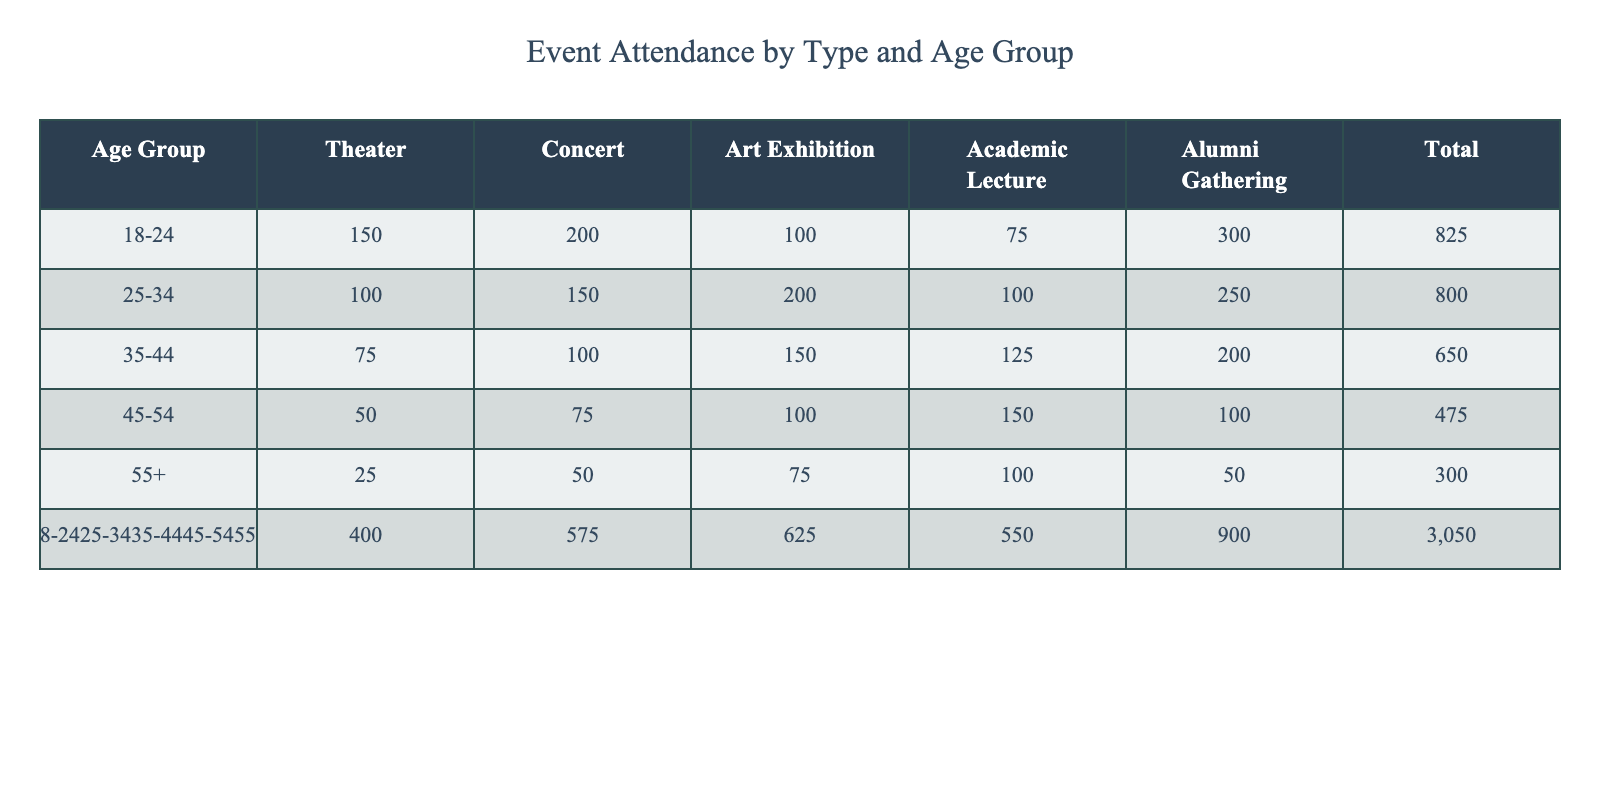What is the total attendance for the 18-24 age group? The total attendance for the 18-24 age group can be found by adding the values from that row. The sum is 150 (Theater) + 200 (Concert) + 100 (Art Exhibition) + 75 (Academic Lecture) + 300 (Alumni Gathering) = 825.
Answer: 825 Which age group had the highest attendance at the Academic Lecture? Upon reviewing the Academic Lecture column, the 35-44 age group has the highest attendance with 125 individuals.
Answer: 35-44 How many attendees were there at the Art Exhibition for those aged 45-54? To find this, we only look at the Art Exhibition column for the 45-54 age group, which shows 100 attendees.
Answer: 100 What is the average attendance for all events from the 55+ age group? The average can be calculated by summing the attendance for the 55+ age group: 25 (Theater) + 50 (Concert) + 75 (Art Exhibition) + 100 (Academic Lecture) + 50 (Alumni Gathering) = 300. Then, divide by the number of events (5), which gives us 300/5 = 60.
Answer: 60 Is the total attendance for the 25-34 age group greater than 600? First, we calculate the total for the 25-34 age group: 100 (Theater) + 150 (Concert) + 200 (Art Exhibition) + 100 (Academic Lecture) + 250 (Alumni Gathering) = 800. Since 800 is greater than 600, the answer is yes.
Answer: Yes Which event type had the least total attendance across all age groups? To find this, we sum each event's attendance across all age groups. Theater = 150 + 100 + 75 + 50 + 25 = 400, Concert = 200 + 150 + 100 + 75 + 50 = 575, Art Exhibition = 100 + 200 + 150 + 100 + 75 = 625, Academic Lecture = 75 + 100 + 125 + 150 + 100 = 550, Alumni Gathering = 300 + 250 + 200 + 100 + 50 = 900. The least is Theatre at 400.
Answer: Theater How many more attendees were there at the Concert compared to the Art Exhibition for age group 35-44? For age group 35-44, the attendance figures are 100 (Concert) and 150 (Art Exhibition). The difference is 150 - 100 = 50.
Answer: 50 Which age group attended Academic Lectures the least, and what was that number? Upon reviewing the Academic Lecture column, the 45-54 age group shows the least attendance with 150 individuals.
Answer: 45-54, 150 What percentage of the total attendees from the 18-24 age group attended Alumni Gatherings? First, we find the total attendance for the 18-24 age group is 825, and the number attending Alumni Gatherings is 300. To find the percentage, we calculate (300/825) * 100 = approximately 36.36%.
Answer: 36.36% 